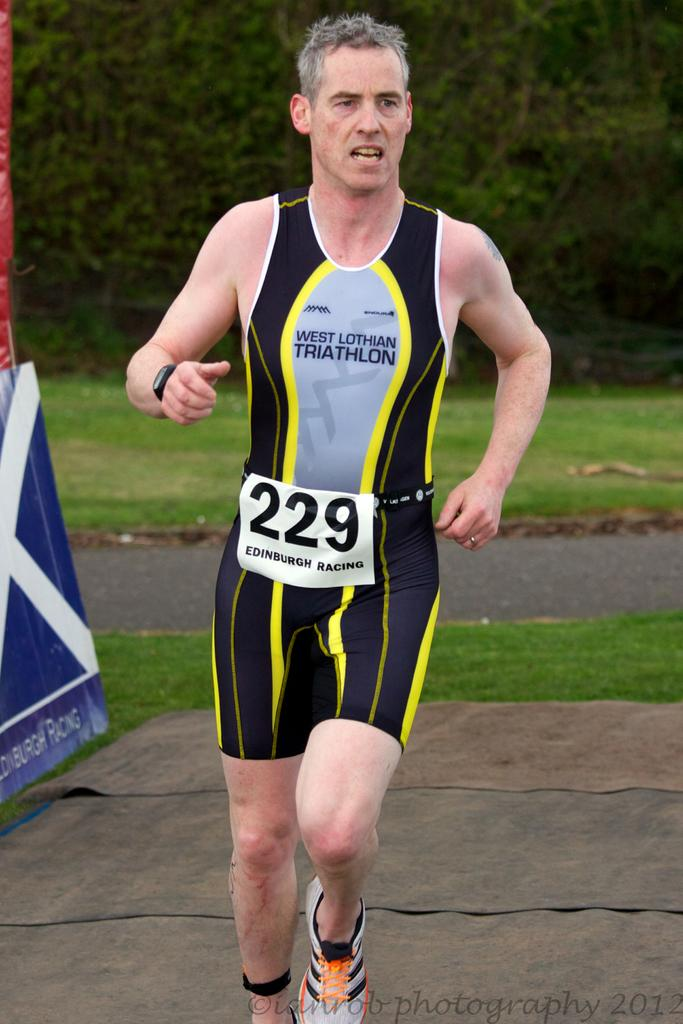<image>
Give a short and clear explanation of the subsequent image. The man is running in the West Lothian Triathlon. 